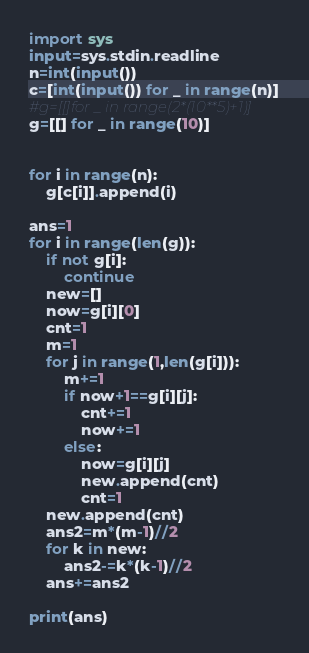Convert code to text. <code><loc_0><loc_0><loc_500><loc_500><_Python_>import sys
input=sys.stdin.readline
n=int(input())
c=[int(input()) for _ in range(n)]
#g=[[]for _ in range(2*(10**5)+1)]
g=[[] for _ in range(10)]


for i in range(n):
    g[c[i]].append(i)

ans=1
for i in range(len(g)):
    if not g[i]:
        continue
    new=[]
    now=g[i][0]
    cnt=1
    m=1
    for j in range(1,len(g[i])):
        m+=1
        if now+1==g[i][j]:
            cnt+=1
            now+=1
        else:
            now=g[i][j]
            new.append(cnt)
            cnt=1
    new.append(cnt)
    ans2=m*(m-1)//2
    for k in new:
        ans2-=k*(k-1)//2
    ans+=ans2

print(ans)
</code> 